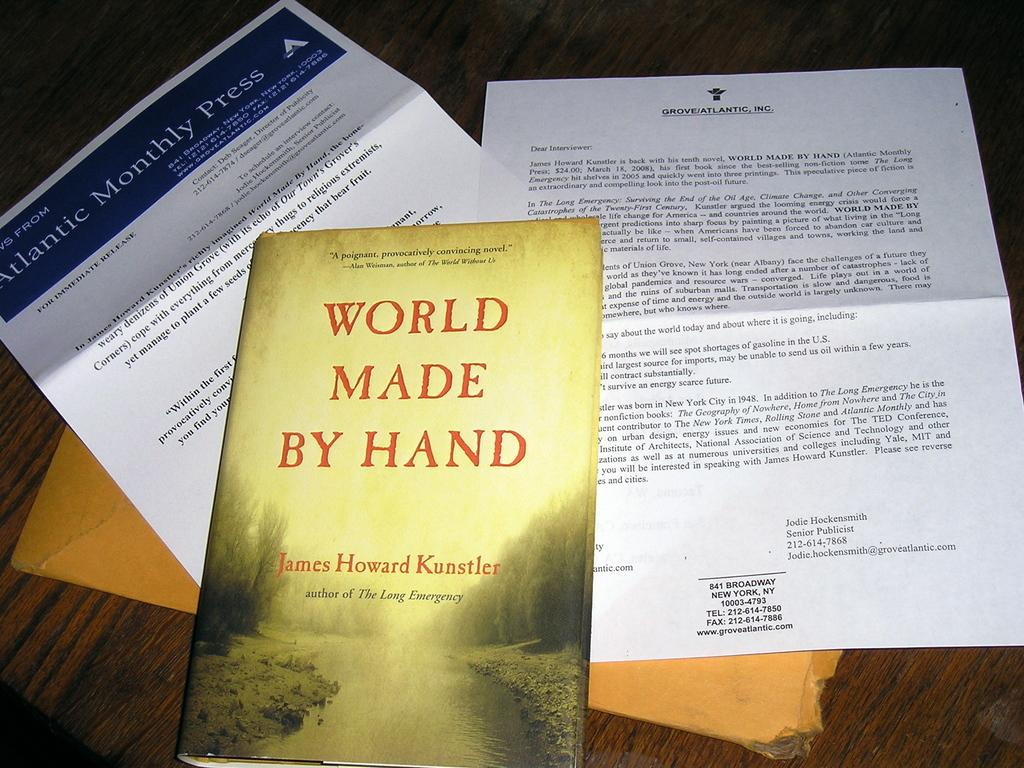<image>
Write a terse but informative summary of the picture. Yellow book with a cover that says "World Made by Hand" on it. 